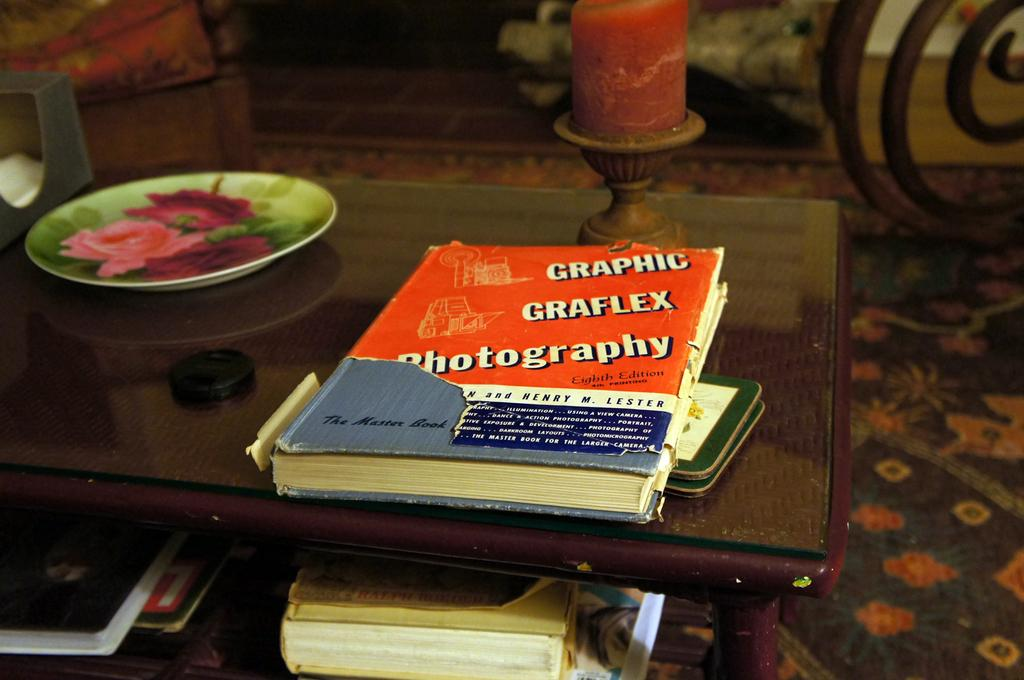<image>
Share a concise interpretation of the image provided. The book is the master book for photography. 